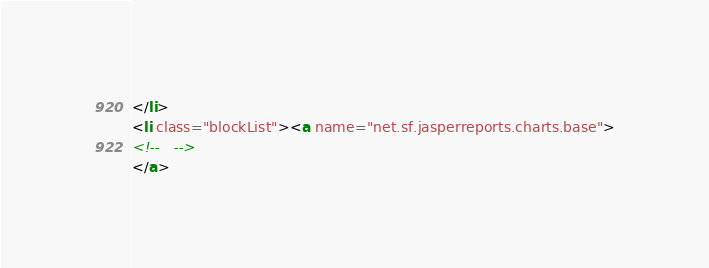<code> <loc_0><loc_0><loc_500><loc_500><_HTML_></li>
<li class="blockList"><a name="net.sf.jasperreports.charts.base">
<!--   -->
</a></code> 